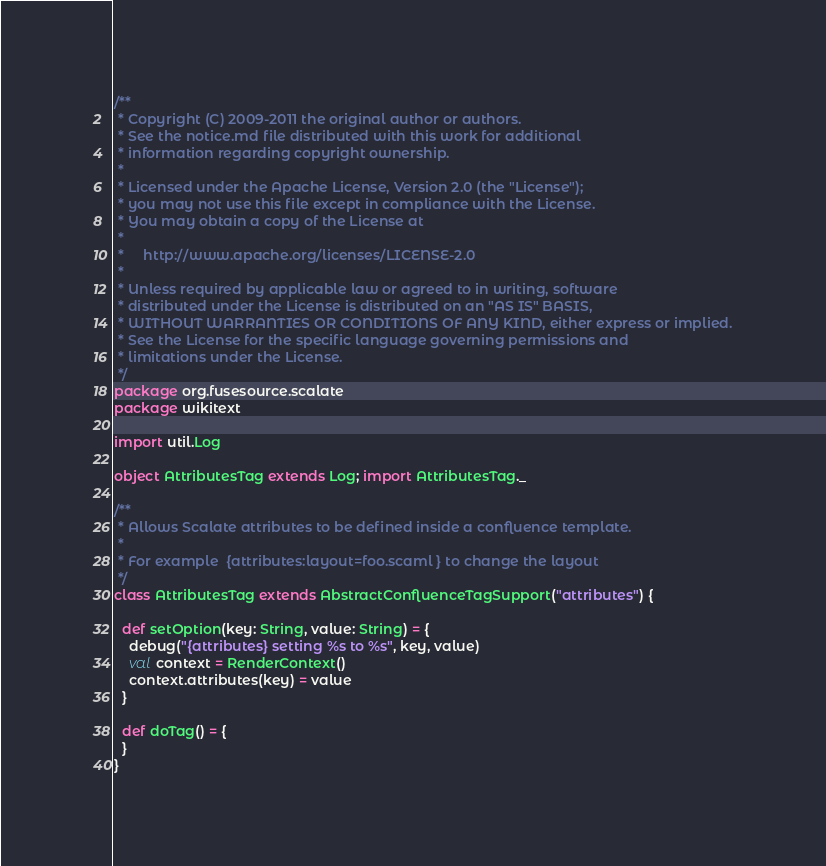<code> <loc_0><loc_0><loc_500><loc_500><_Scala_>/**
 * Copyright (C) 2009-2011 the original author or authors.
 * See the notice.md file distributed with this work for additional
 * information regarding copyright ownership.
 *
 * Licensed under the Apache License, Version 2.0 (the "License");
 * you may not use this file except in compliance with the License.
 * You may obtain a copy of the License at
 *
 *     http://www.apache.org/licenses/LICENSE-2.0
 *
 * Unless required by applicable law or agreed to in writing, software
 * distributed under the License is distributed on an "AS IS" BASIS,
 * WITHOUT WARRANTIES OR CONDITIONS OF ANY KIND, either express or implied.
 * See the License for the specific language governing permissions and
 * limitations under the License.
 */
package org.fusesource.scalate
package wikitext

import util.Log

object AttributesTag extends Log; import AttributesTag._

/**
 * Allows Scalate attributes to be defined inside a confluence template.
 *
 * For example  {attributes:layout=foo.scaml } to change the layout
 */
class AttributesTag extends AbstractConfluenceTagSupport("attributes") {

  def setOption(key: String, value: String) = {
    debug("{attributes} setting %s to %s", key, value)
    val context = RenderContext()
    context.attributes(key) = value
  }

  def doTag() = {
  }
}

</code> 